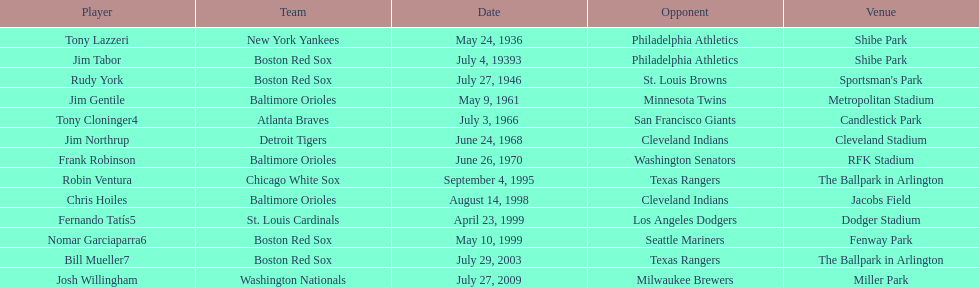Which teams played between the years 1960 and 1970? Baltimore Orioles, Atlanta Braves, Detroit Tigers, Baltimore Orioles. Of these teams that played, which ones played against the cleveland indians? Detroit Tigers. On what day did these two teams play? June 24, 1968. 